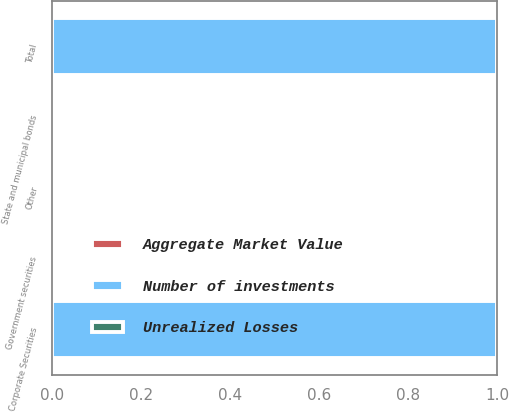<chart> <loc_0><loc_0><loc_500><loc_500><stacked_bar_chart><ecel><fcel>Government securities<fcel>State and municipal bonds<fcel>Corporate Securities<fcel>Other<fcel>Total<nl><fcel>Number of investments<fcel>0<fcel>0<fcel>1<fcel>0<fcel>1<nl><fcel>Unrealized Losses<fcel>0<fcel>0<fcel>0<fcel>0<fcel>0<nl><fcel>Aggregate Market Value<fcel>0<fcel>0<fcel>0<fcel>0<fcel>0<nl></chart> 